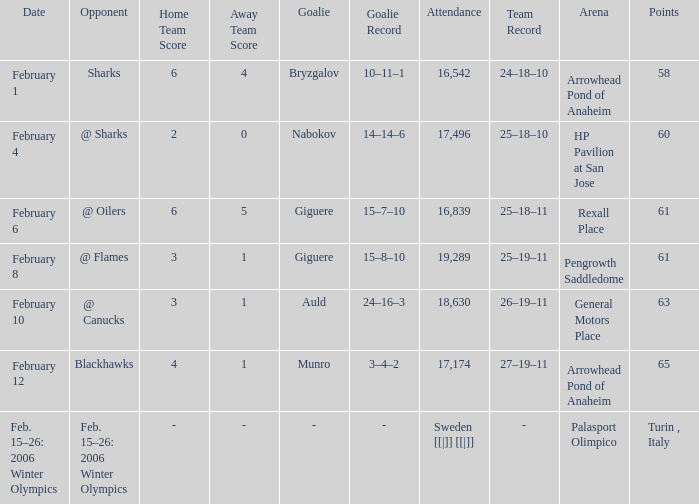What is the record at Arrowhead Pond of Anaheim, when the loss was Bryzgalov (10–11–1)? 24–18–10. 